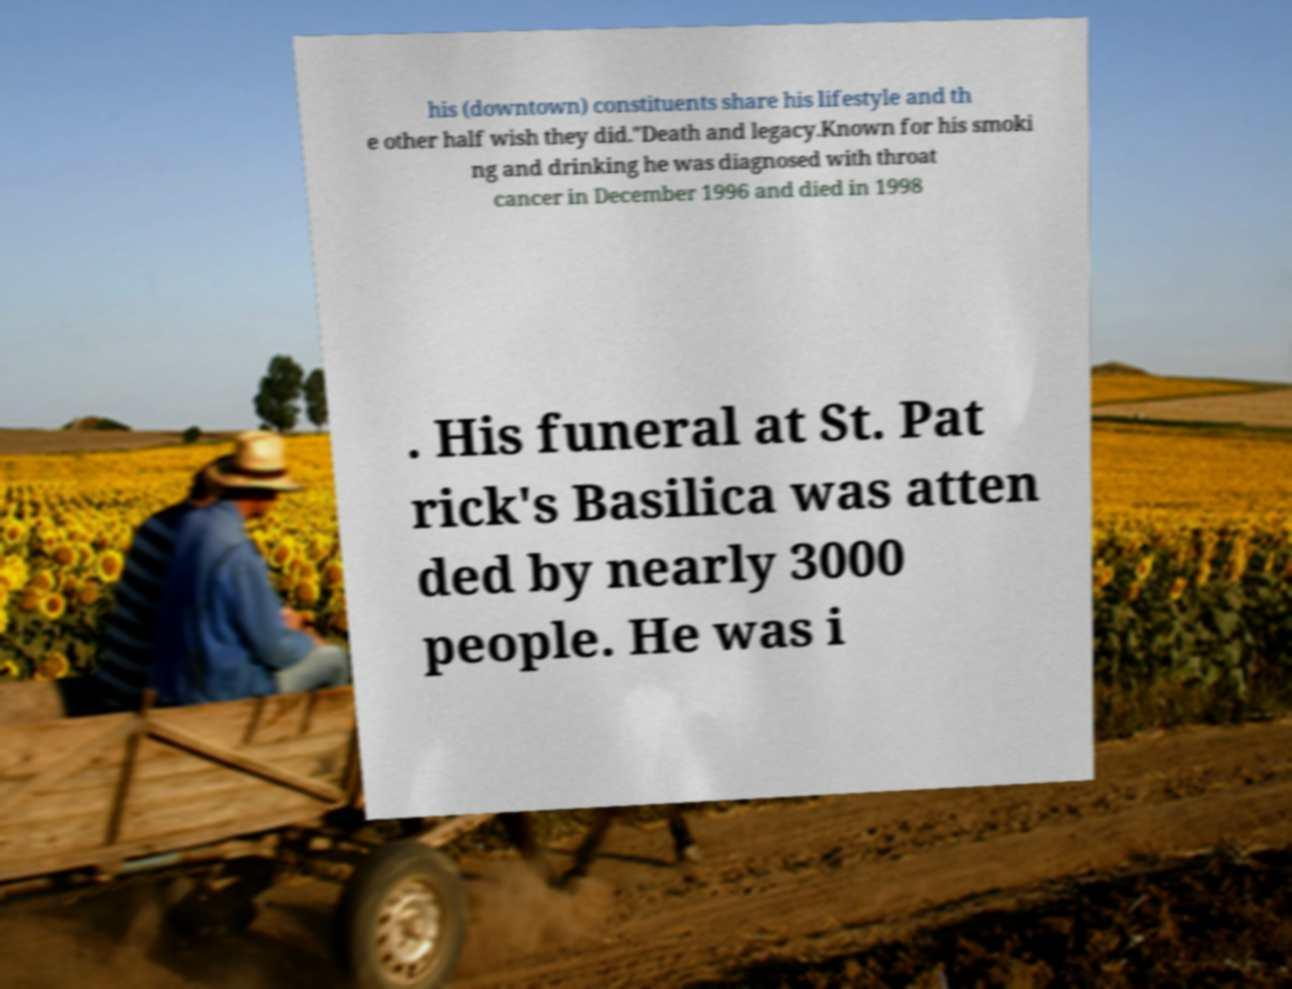Please read and relay the text visible in this image. What does it say? his (downtown) constituents share his lifestyle and th e other half wish they did."Death and legacy.Known for his smoki ng and drinking he was diagnosed with throat cancer in December 1996 and died in 1998 . His funeral at St. Pat rick's Basilica was atten ded by nearly 3000 people. He was i 